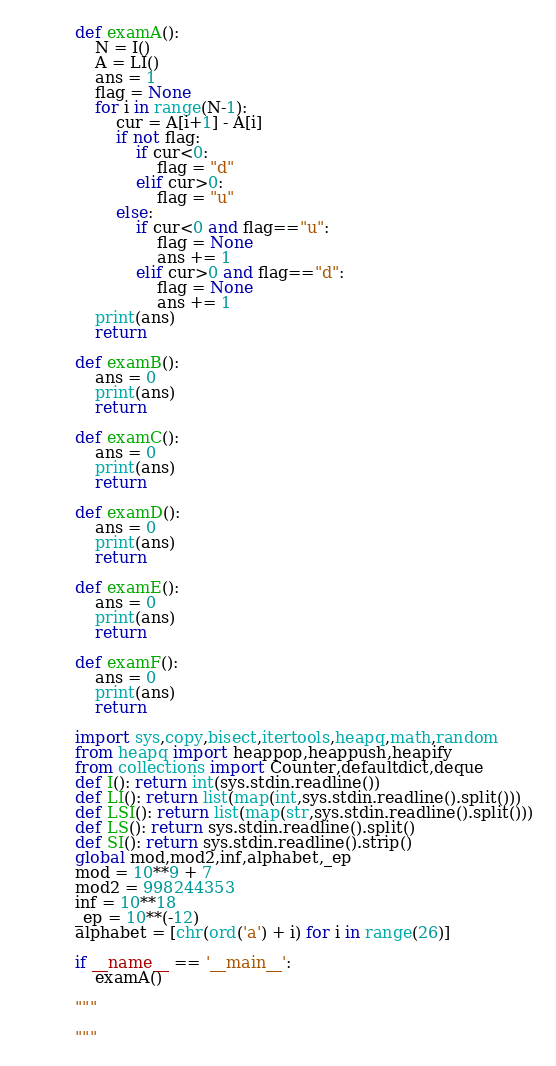Convert code to text. <code><loc_0><loc_0><loc_500><loc_500><_Python_>def examA():
    N = I()
    A = LI()
    ans = 1
    flag = None
    for i in range(N-1):
        cur = A[i+1] - A[i]
        if not flag:
            if cur<0:
                flag = "d"
            elif cur>0:
                flag = "u"
        else:
            if cur<0 and flag=="u":
                flag = None
                ans += 1
            elif cur>0 and flag=="d":
                flag = None
                ans += 1
    print(ans)
    return

def examB():
    ans = 0
    print(ans)
    return

def examC():
    ans = 0
    print(ans)
    return

def examD():
    ans = 0
    print(ans)
    return

def examE():
    ans = 0
    print(ans)
    return

def examF():
    ans = 0
    print(ans)
    return

import sys,copy,bisect,itertools,heapq,math,random
from heapq import heappop,heappush,heapify
from collections import Counter,defaultdict,deque
def I(): return int(sys.stdin.readline())
def LI(): return list(map(int,sys.stdin.readline().split()))
def LSI(): return list(map(str,sys.stdin.readline().split()))
def LS(): return sys.stdin.readline().split()
def SI(): return sys.stdin.readline().strip()
global mod,mod2,inf,alphabet,_ep
mod = 10**9 + 7
mod2 = 998244353
inf = 10**18
_ep = 10**(-12)
alphabet = [chr(ord('a') + i) for i in range(26)]

if __name__ == '__main__':
    examA()

"""

"""</code> 